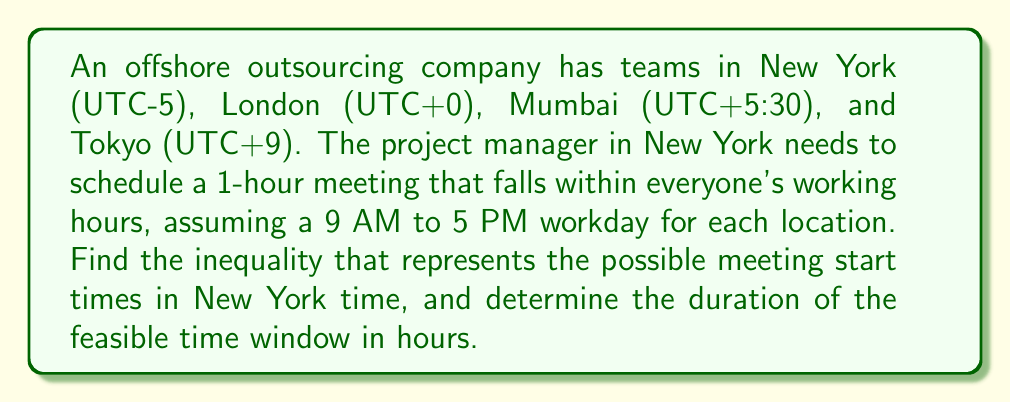What is the answer to this math problem? Let's approach this step-by-step:

1) First, let's convert all times to New York time (UTC-5):
   - New York: 9 AM to 5 PM
   - London: 4 AM to 12 PM (5 hours behind)
   - Mumbai: 10:30 PM (previous day) to 6:30 AM (9.5 hours ahead)
   - Tokyo: 7 PM (previous day) to 3 AM (14 hours ahead)

2) The meeting must start after all locations have begun their workday and end before any location ends their workday. Let $x$ be the start time of the meeting in New York (in hours after midnight).

3) The constraints for each location:
   - New York: $9 \leq x < 16$ (meeting must end by 5 PM)
   - London: $4 \leq x < 11$ (meeting must end by 12 PM NY time)
   - Mumbai: $x \geq 9$ (workday starts at 9 AM NY time)
   - Tokyo: $x < 2$ (workday ends at 3 AM NY time)

4) Combining these constraints:

   $$ 9 \leq x < 2 $$

5) However, this inequality has no solution as written. We need to adjust for the fact that Tokyo's workday crosses midnight in New York time. The actual feasible time is:

   $$ 9 \leq x < 16 $$

6) To find the duration of the feasible time window:

   $$ 16 - 9 = 7 \text{ hours} $$
Answer: The inequality representing possible meeting start times in New York time is $9 \leq x < 16$, where $x$ is the number of hours after midnight. The duration of the feasible time window is 7 hours. 